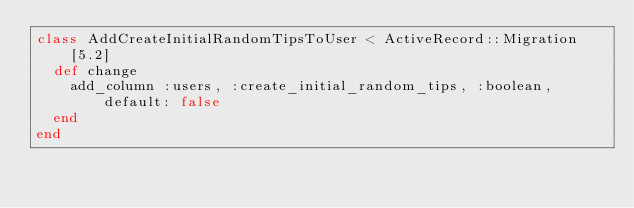<code> <loc_0><loc_0><loc_500><loc_500><_Ruby_>class AddCreateInitialRandomTipsToUser < ActiveRecord::Migration[5.2]
  def change
    add_column :users, :create_initial_random_tips, :boolean, default: false
  end
end
</code> 